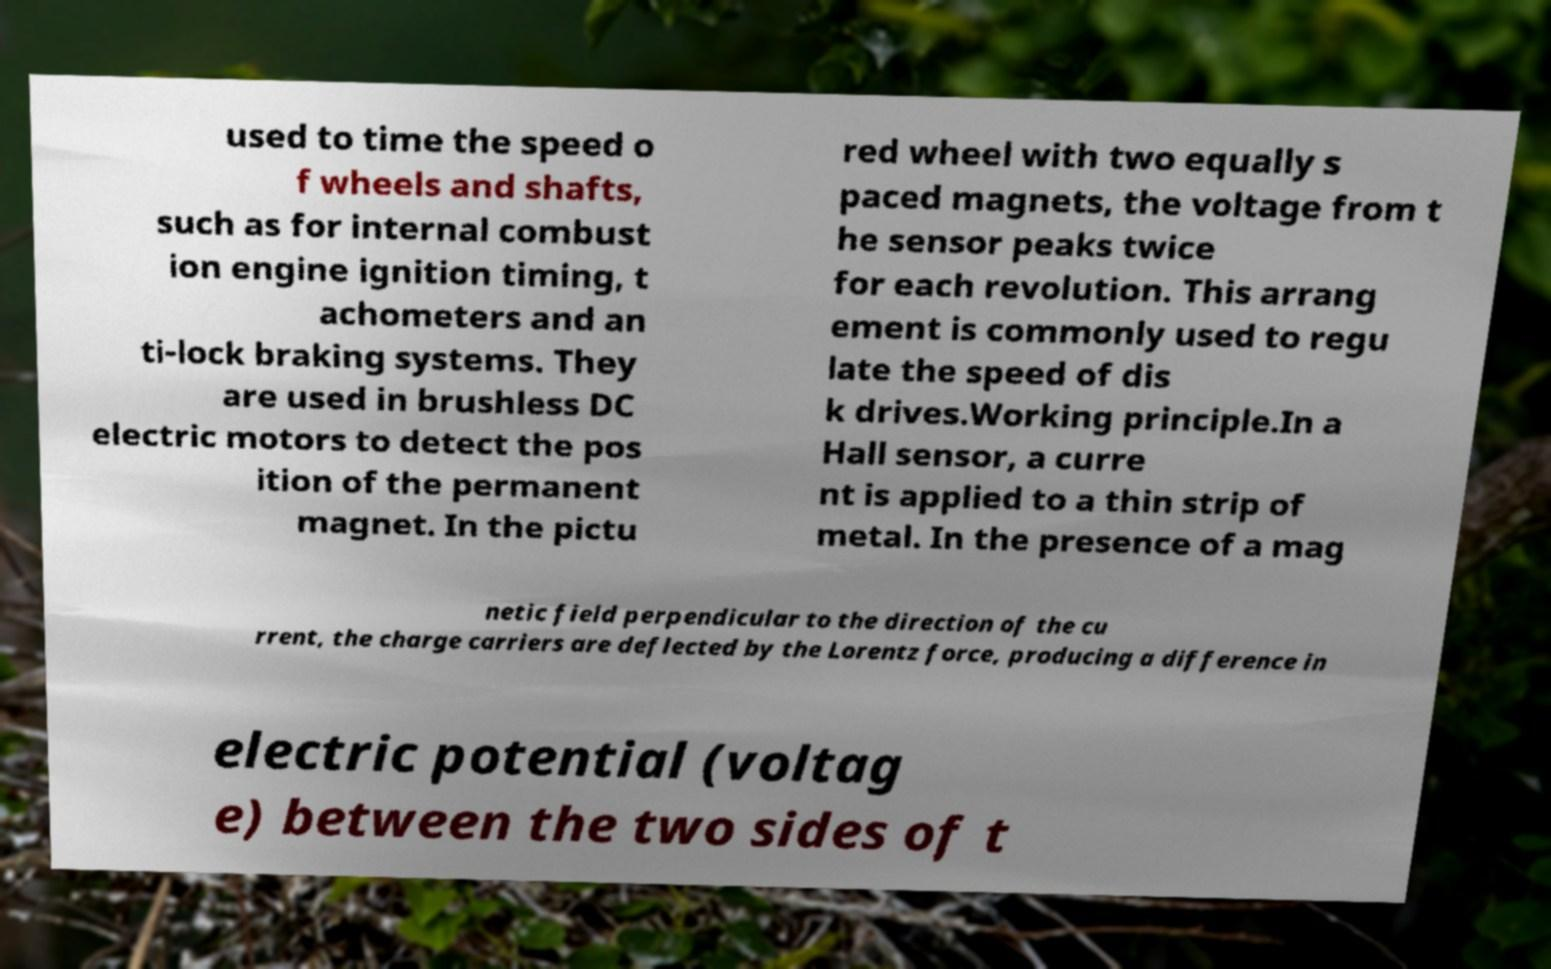For documentation purposes, I need the text within this image transcribed. Could you provide that? used to time the speed o f wheels and shafts, such as for internal combust ion engine ignition timing, t achometers and an ti-lock braking systems. They are used in brushless DC electric motors to detect the pos ition of the permanent magnet. In the pictu red wheel with two equally s paced magnets, the voltage from t he sensor peaks twice for each revolution. This arrang ement is commonly used to regu late the speed of dis k drives.Working principle.In a Hall sensor, a curre nt is applied to a thin strip of metal. In the presence of a mag netic field perpendicular to the direction of the cu rrent, the charge carriers are deflected by the Lorentz force, producing a difference in electric potential (voltag e) between the two sides of t 